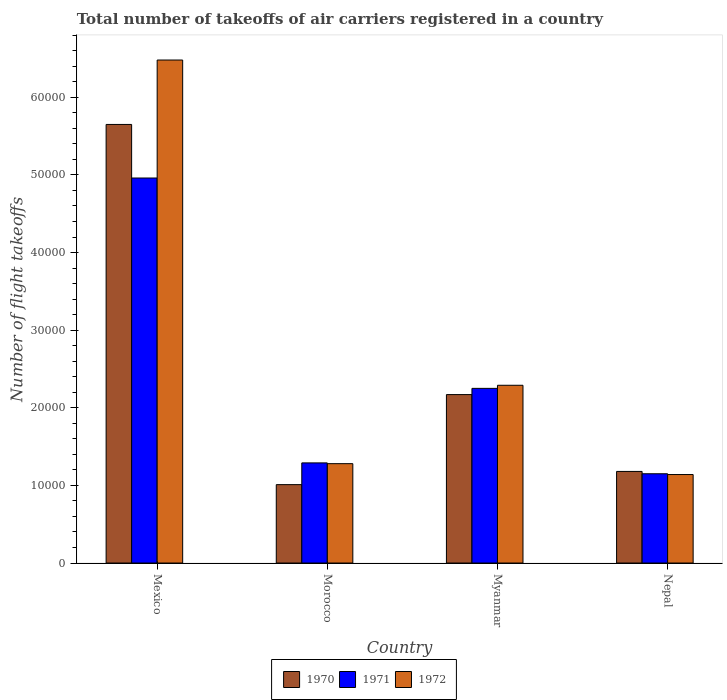How many different coloured bars are there?
Give a very brief answer. 3. How many groups of bars are there?
Offer a terse response. 4. Are the number of bars per tick equal to the number of legend labels?
Keep it short and to the point. Yes. Are the number of bars on each tick of the X-axis equal?
Offer a terse response. Yes. How many bars are there on the 1st tick from the right?
Offer a very short reply. 3. What is the label of the 3rd group of bars from the left?
Give a very brief answer. Myanmar. What is the total number of flight takeoffs in 1970 in Nepal?
Your answer should be compact. 1.18e+04. Across all countries, what is the maximum total number of flight takeoffs in 1972?
Offer a terse response. 6.48e+04. Across all countries, what is the minimum total number of flight takeoffs in 1972?
Ensure brevity in your answer.  1.14e+04. In which country was the total number of flight takeoffs in 1970 maximum?
Make the answer very short. Mexico. In which country was the total number of flight takeoffs in 1971 minimum?
Provide a succinct answer. Nepal. What is the total total number of flight takeoffs in 1971 in the graph?
Provide a short and direct response. 9.65e+04. What is the difference between the total number of flight takeoffs in 1972 in Mexico and that in Myanmar?
Offer a very short reply. 4.19e+04. What is the difference between the total number of flight takeoffs in 1971 in Myanmar and the total number of flight takeoffs in 1970 in Mexico?
Offer a terse response. -3.40e+04. What is the average total number of flight takeoffs in 1971 per country?
Your answer should be very brief. 2.41e+04. What is the ratio of the total number of flight takeoffs in 1970 in Myanmar to that in Nepal?
Offer a terse response. 1.84. Is the total number of flight takeoffs in 1972 in Mexico less than that in Myanmar?
Offer a terse response. No. What is the difference between the highest and the second highest total number of flight takeoffs in 1970?
Your answer should be very brief. -9900. What is the difference between the highest and the lowest total number of flight takeoffs in 1972?
Ensure brevity in your answer.  5.34e+04. In how many countries, is the total number of flight takeoffs in 1972 greater than the average total number of flight takeoffs in 1972 taken over all countries?
Your answer should be very brief. 1. What does the 2nd bar from the left in Mexico represents?
Your answer should be very brief. 1971. What does the 1st bar from the right in Mexico represents?
Provide a succinct answer. 1972. Is it the case that in every country, the sum of the total number of flight takeoffs in 1970 and total number of flight takeoffs in 1972 is greater than the total number of flight takeoffs in 1971?
Your answer should be compact. Yes. How many countries are there in the graph?
Your response must be concise. 4. What is the difference between two consecutive major ticks on the Y-axis?
Make the answer very short. 10000. Are the values on the major ticks of Y-axis written in scientific E-notation?
Offer a very short reply. No. Does the graph contain any zero values?
Give a very brief answer. No. Does the graph contain grids?
Offer a terse response. No. Where does the legend appear in the graph?
Your answer should be compact. Bottom center. How are the legend labels stacked?
Your answer should be compact. Horizontal. What is the title of the graph?
Provide a succinct answer. Total number of takeoffs of air carriers registered in a country. What is the label or title of the Y-axis?
Give a very brief answer. Number of flight takeoffs. What is the Number of flight takeoffs in 1970 in Mexico?
Your answer should be very brief. 5.65e+04. What is the Number of flight takeoffs in 1971 in Mexico?
Your response must be concise. 4.96e+04. What is the Number of flight takeoffs in 1972 in Mexico?
Provide a short and direct response. 6.48e+04. What is the Number of flight takeoffs in 1970 in Morocco?
Keep it short and to the point. 1.01e+04. What is the Number of flight takeoffs in 1971 in Morocco?
Ensure brevity in your answer.  1.29e+04. What is the Number of flight takeoffs in 1972 in Morocco?
Your answer should be compact. 1.28e+04. What is the Number of flight takeoffs of 1970 in Myanmar?
Offer a terse response. 2.17e+04. What is the Number of flight takeoffs of 1971 in Myanmar?
Provide a short and direct response. 2.25e+04. What is the Number of flight takeoffs in 1972 in Myanmar?
Provide a short and direct response. 2.29e+04. What is the Number of flight takeoffs of 1970 in Nepal?
Provide a short and direct response. 1.18e+04. What is the Number of flight takeoffs of 1971 in Nepal?
Your answer should be very brief. 1.15e+04. What is the Number of flight takeoffs in 1972 in Nepal?
Provide a short and direct response. 1.14e+04. Across all countries, what is the maximum Number of flight takeoffs in 1970?
Provide a short and direct response. 5.65e+04. Across all countries, what is the maximum Number of flight takeoffs in 1971?
Give a very brief answer. 4.96e+04. Across all countries, what is the maximum Number of flight takeoffs of 1972?
Provide a succinct answer. 6.48e+04. Across all countries, what is the minimum Number of flight takeoffs of 1970?
Offer a very short reply. 1.01e+04. Across all countries, what is the minimum Number of flight takeoffs of 1971?
Make the answer very short. 1.15e+04. Across all countries, what is the minimum Number of flight takeoffs in 1972?
Keep it short and to the point. 1.14e+04. What is the total Number of flight takeoffs in 1970 in the graph?
Your answer should be compact. 1.00e+05. What is the total Number of flight takeoffs in 1971 in the graph?
Your answer should be compact. 9.65e+04. What is the total Number of flight takeoffs in 1972 in the graph?
Provide a short and direct response. 1.12e+05. What is the difference between the Number of flight takeoffs in 1970 in Mexico and that in Morocco?
Offer a terse response. 4.64e+04. What is the difference between the Number of flight takeoffs in 1971 in Mexico and that in Morocco?
Make the answer very short. 3.67e+04. What is the difference between the Number of flight takeoffs of 1972 in Mexico and that in Morocco?
Your response must be concise. 5.20e+04. What is the difference between the Number of flight takeoffs in 1970 in Mexico and that in Myanmar?
Offer a terse response. 3.48e+04. What is the difference between the Number of flight takeoffs in 1971 in Mexico and that in Myanmar?
Provide a short and direct response. 2.71e+04. What is the difference between the Number of flight takeoffs in 1972 in Mexico and that in Myanmar?
Your answer should be very brief. 4.19e+04. What is the difference between the Number of flight takeoffs of 1970 in Mexico and that in Nepal?
Your answer should be very brief. 4.47e+04. What is the difference between the Number of flight takeoffs in 1971 in Mexico and that in Nepal?
Ensure brevity in your answer.  3.81e+04. What is the difference between the Number of flight takeoffs in 1972 in Mexico and that in Nepal?
Offer a very short reply. 5.34e+04. What is the difference between the Number of flight takeoffs of 1970 in Morocco and that in Myanmar?
Offer a very short reply. -1.16e+04. What is the difference between the Number of flight takeoffs in 1971 in Morocco and that in Myanmar?
Your answer should be very brief. -9600. What is the difference between the Number of flight takeoffs in 1972 in Morocco and that in Myanmar?
Offer a very short reply. -1.01e+04. What is the difference between the Number of flight takeoffs in 1970 in Morocco and that in Nepal?
Offer a very short reply. -1700. What is the difference between the Number of flight takeoffs of 1971 in Morocco and that in Nepal?
Give a very brief answer. 1400. What is the difference between the Number of flight takeoffs in 1972 in Morocco and that in Nepal?
Provide a short and direct response. 1400. What is the difference between the Number of flight takeoffs in 1970 in Myanmar and that in Nepal?
Your answer should be compact. 9900. What is the difference between the Number of flight takeoffs of 1971 in Myanmar and that in Nepal?
Your response must be concise. 1.10e+04. What is the difference between the Number of flight takeoffs of 1972 in Myanmar and that in Nepal?
Ensure brevity in your answer.  1.15e+04. What is the difference between the Number of flight takeoffs of 1970 in Mexico and the Number of flight takeoffs of 1971 in Morocco?
Offer a terse response. 4.36e+04. What is the difference between the Number of flight takeoffs in 1970 in Mexico and the Number of flight takeoffs in 1972 in Morocco?
Your answer should be very brief. 4.37e+04. What is the difference between the Number of flight takeoffs of 1971 in Mexico and the Number of flight takeoffs of 1972 in Morocco?
Ensure brevity in your answer.  3.68e+04. What is the difference between the Number of flight takeoffs of 1970 in Mexico and the Number of flight takeoffs of 1971 in Myanmar?
Your response must be concise. 3.40e+04. What is the difference between the Number of flight takeoffs of 1970 in Mexico and the Number of flight takeoffs of 1972 in Myanmar?
Give a very brief answer. 3.36e+04. What is the difference between the Number of flight takeoffs in 1971 in Mexico and the Number of flight takeoffs in 1972 in Myanmar?
Give a very brief answer. 2.67e+04. What is the difference between the Number of flight takeoffs of 1970 in Mexico and the Number of flight takeoffs of 1971 in Nepal?
Ensure brevity in your answer.  4.50e+04. What is the difference between the Number of flight takeoffs in 1970 in Mexico and the Number of flight takeoffs in 1972 in Nepal?
Make the answer very short. 4.51e+04. What is the difference between the Number of flight takeoffs of 1971 in Mexico and the Number of flight takeoffs of 1972 in Nepal?
Your answer should be very brief. 3.82e+04. What is the difference between the Number of flight takeoffs of 1970 in Morocco and the Number of flight takeoffs of 1971 in Myanmar?
Your response must be concise. -1.24e+04. What is the difference between the Number of flight takeoffs in 1970 in Morocco and the Number of flight takeoffs in 1972 in Myanmar?
Offer a very short reply. -1.28e+04. What is the difference between the Number of flight takeoffs in 1971 in Morocco and the Number of flight takeoffs in 1972 in Myanmar?
Provide a succinct answer. -10000. What is the difference between the Number of flight takeoffs of 1970 in Morocco and the Number of flight takeoffs of 1971 in Nepal?
Make the answer very short. -1400. What is the difference between the Number of flight takeoffs of 1970 in Morocco and the Number of flight takeoffs of 1972 in Nepal?
Your answer should be compact. -1300. What is the difference between the Number of flight takeoffs of 1971 in Morocco and the Number of flight takeoffs of 1972 in Nepal?
Give a very brief answer. 1500. What is the difference between the Number of flight takeoffs of 1970 in Myanmar and the Number of flight takeoffs of 1971 in Nepal?
Offer a terse response. 1.02e+04. What is the difference between the Number of flight takeoffs in 1970 in Myanmar and the Number of flight takeoffs in 1972 in Nepal?
Give a very brief answer. 1.03e+04. What is the difference between the Number of flight takeoffs in 1971 in Myanmar and the Number of flight takeoffs in 1972 in Nepal?
Offer a terse response. 1.11e+04. What is the average Number of flight takeoffs in 1970 per country?
Your response must be concise. 2.50e+04. What is the average Number of flight takeoffs of 1971 per country?
Offer a very short reply. 2.41e+04. What is the average Number of flight takeoffs in 1972 per country?
Ensure brevity in your answer.  2.80e+04. What is the difference between the Number of flight takeoffs of 1970 and Number of flight takeoffs of 1971 in Mexico?
Keep it short and to the point. 6900. What is the difference between the Number of flight takeoffs of 1970 and Number of flight takeoffs of 1972 in Mexico?
Your answer should be compact. -8300. What is the difference between the Number of flight takeoffs of 1971 and Number of flight takeoffs of 1972 in Mexico?
Your response must be concise. -1.52e+04. What is the difference between the Number of flight takeoffs in 1970 and Number of flight takeoffs in 1971 in Morocco?
Ensure brevity in your answer.  -2800. What is the difference between the Number of flight takeoffs in 1970 and Number of flight takeoffs in 1972 in Morocco?
Ensure brevity in your answer.  -2700. What is the difference between the Number of flight takeoffs of 1971 and Number of flight takeoffs of 1972 in Morocco?
Provide a succinct answer. 100. What is the difference between the Number of flight takeoffs of 1970 and Number of flight takeoffs of 1971 in Myanmar?
Your answer should be very brief. -800. What is the difference between the Number of flight takeoffs in 1970 and Number of flight takeoffs in 1972 in Myanmar?
Make the answer very short. -1200. What is the difference between the Number of flight takeoffs in 1971 and Number of flight takeoffs in 1972 in Myanmar?
Make the answer very short. -400. What is the difference between the Number of flight takeoffs of 1970 and Number of flight takeoffs of 1971 in Nepal?
Your response must be concise. 300. What is the difference between the Number of flight takeoffs of 1970 and Number of flight takeoffs of 1972 in Nepal?
Your answer should be compact. 400. What is the ratio of the Number of flight takeoffs in 1970 in Mexico to that in Morocco?
Offer a very short reply. 5.59. What is the ratio of the Number of flight takeoffs of 1971 in Mexico to that in Morocco?
Your answer should be compact. 3.85. What is the ratio of the Number of flight takeoffs of 1972 in Mexico to that in Morocco?
Offer a very short reply. 5.06. What is the ratio of the Number of flight takeoffs of 1970 in Mexico to that in Myanmar?
Offer a terse response. 2.6. What is the ratio of the Number of flight takeoffs of 1971 in Mexico to that in Myanmar?
Your answer should be very brief. 2.2. What is the ratio of the Number of flight takeoffs in 1972 in Mexico to that in Myanmar?
Offer a very short reply. 2.83. What is the ratio of the Number of flight takeoffs of 1970 in Mexico to that in Nepal?
Provide a short and direct response. 4.79. What is the ratio of the Number of flight takeoffs of 1971 in Mexico to that in Nepal?
Offer a very short reply. 4.31. What is the ratio of the Number of flight takeoffs in 1972 in Mexico to that in Nepal?
Keep it short and to the point. 5.68. What is the ratio of the Number of flight takeoffs of 1970 in Morocco to that in Myanmar?
Provide a short and direct response. 0.47. What is the ratio of the Number of flight takeoffs in 1971 in Morocco to that in Myanmar?
Keep it short and to the point. 0.57. What is the ratio of the Number of flight takeoffs of 1972 in Morocco to that in Myanmar?
Offer a terse response. 0.56. What is the ratio of the Number of flight takeoffs of 1970 in Morocco to that in Nepal?
Provide a succinct answer. 0.86. What is the ratio of the Number of flight takeoffs of 1971 in Morocco to that in Nepal?
Keep it short and to the point. 1.12. What is the ratio of the Number of flight takeoffs in 1972 in Morocco to that in Nepal?
Ensure brevity in your answer.  1.12. What is the ratio of the Number of flight takeoffs of 1970 in Myanmar to that in Nepal?
Your answer should be very brief. 1.84. What is the ratio of the Number of flight takeoffs of 1971 in Myanmar to that in Nepal?
Provide a succinct answer. 1.96. What is the ratio of the Number of flight takeoffs in 1972 in Myanmar to that in Nepal?
Offer a very short reply. 2.01. What is the difference between the highest and the second highest Number of flight takeoffs of 1970?
Your answer should be compact. 3.48e+04. What is the difference between the highest and the second highest Number of flight takeoffs in 1971?
Make the answer very short. 2.71e+04. What is the difference between the highest and the second highest Number of flight takeoffs of 1972?
Your answer should be very brief. 4.19e+04. What is the difference between the highest and the lowest Number of flight takeoffs in 1970?
Keep it short and to the point. 4.64e+04. What is the difference between the highest and the lowest Number of flight takeoffs of 1971?
Keep it short and to the point. 3.81e+04. What is the difference between the highest and the lowest Number of flight takeoffs in 1972?
Provide a short and direct response. 5.34e+04. 